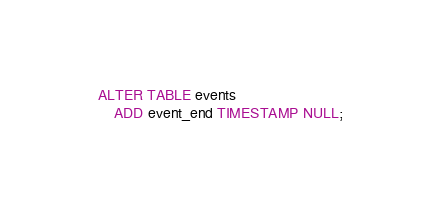<code> <loc_0><loc_0><loc_500><loc_500><_SQL_>ALTER TABLE events
    ADD event_end TIMESTAMP NULL;</code> 